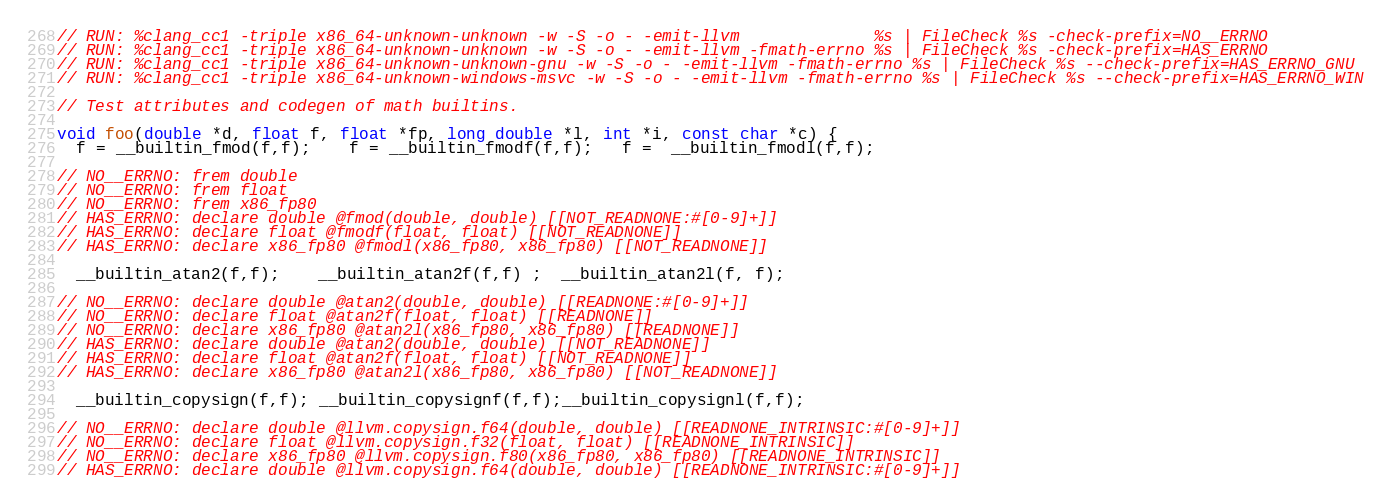<code> <loc_0><loc_0><loc_500><loc_500><_C_>// RUN: %clang_cc1 -triple x86_64-unknown-unknown -w -S -o - -emit-llvm              %s | FileCheck %s -check-prefix=NO__ERRNO
// RUN: %clang_cc1 -triple x86_64-unknown-unknown -w -S -o - -emit-llvm -fmath-errno %s | FileCheck %s -check-prefix=HAS_ERRNO
// RUN: %clang_cc1 -triple x86_64-unknown-unknown-gnu -w -S -o - -emit-llvm -fmath-errno %s | FileCheck %s --check-prefix=HAS_ERRNO_GNU
// RUN: %clang_cc1 -triple x86_64-unknown-windows-msvc -w -S -o - -emit-llvm -fmath-errno %s | FileCheck %s --check-prefix=HAS_ERRNO_WIN

// Test attributes and codegen of math builtins.

void foo(double *d, float f, float *fp, long double *l, int *i, const char *c) {
  f = __builtin_fmod(f,f);    f = __builtin_fmodf(f,f);   f =  __builtin_fmodl(f,f);

// NO__ERRNO: frem double
// NO__ERRNO: frem float
// NO__ERRNO: frem x86_fp80
// HAS_ERRNO: declare double @fmod(double, double) [[NOT_READNONE:#[0-9]+]]
// HAS_ERRNO: declare float @fmodf(float, float) [[NOT_READNONE]]
// HAS_ERRNO: declare x86_fp80 @fmodl(x86_fp80, x86_fp80) [[NOT_READNONE]]

  __builtin_atan2(f,f);    __builtin_atan2f(f,f) ;  __builtin_atan2l(f, f);

// NO__ERRNO: declare double @atan2(double, double) [[READNONE:#[0-9]+]]
// NO__ERRNO: declare float @atan2f(float, float) [[READNONE]]
// NO__ERRNO: declare x86_fp80 @atan2l(x86_fp80, x86_fp80) [[READNONE]]
// HAS_ERRNO: declare double @atan2(double, double) [[NOT_READNONE]]
// HAS_ERRNO: declare float @atan2f(float, float) [[NOT_READNONE]]
// HAS_ERRNO: declare x86_fp80 @atan2l(x86_fp80, x86_fp80) [[NOT_READNONE]]

  __builtin_copysign(f,f); __builtin_copysignf(f,f);__builtin_copysignl(f,f);

// NO__ERRNO: declare double @llvm.copysign.f64(double, double) [[READNONE_INTRINSIC:#[0-9]+]]
// NO__ERRNO: declare float @llvm.copysign.f32(float, float) [[READNONE_INTRINSIC]]
// NO__ERRNO: declare x86_fp80 @llvm.copysign.f80(x86_fp80, x86_fp80) [[READNONE_INTRINSIC]]
// HAS_ERRNO: declare double @llvm.copysign.f64(double, double) [[READNONE_INTRINSIC:#[0-9]+]]</code> 